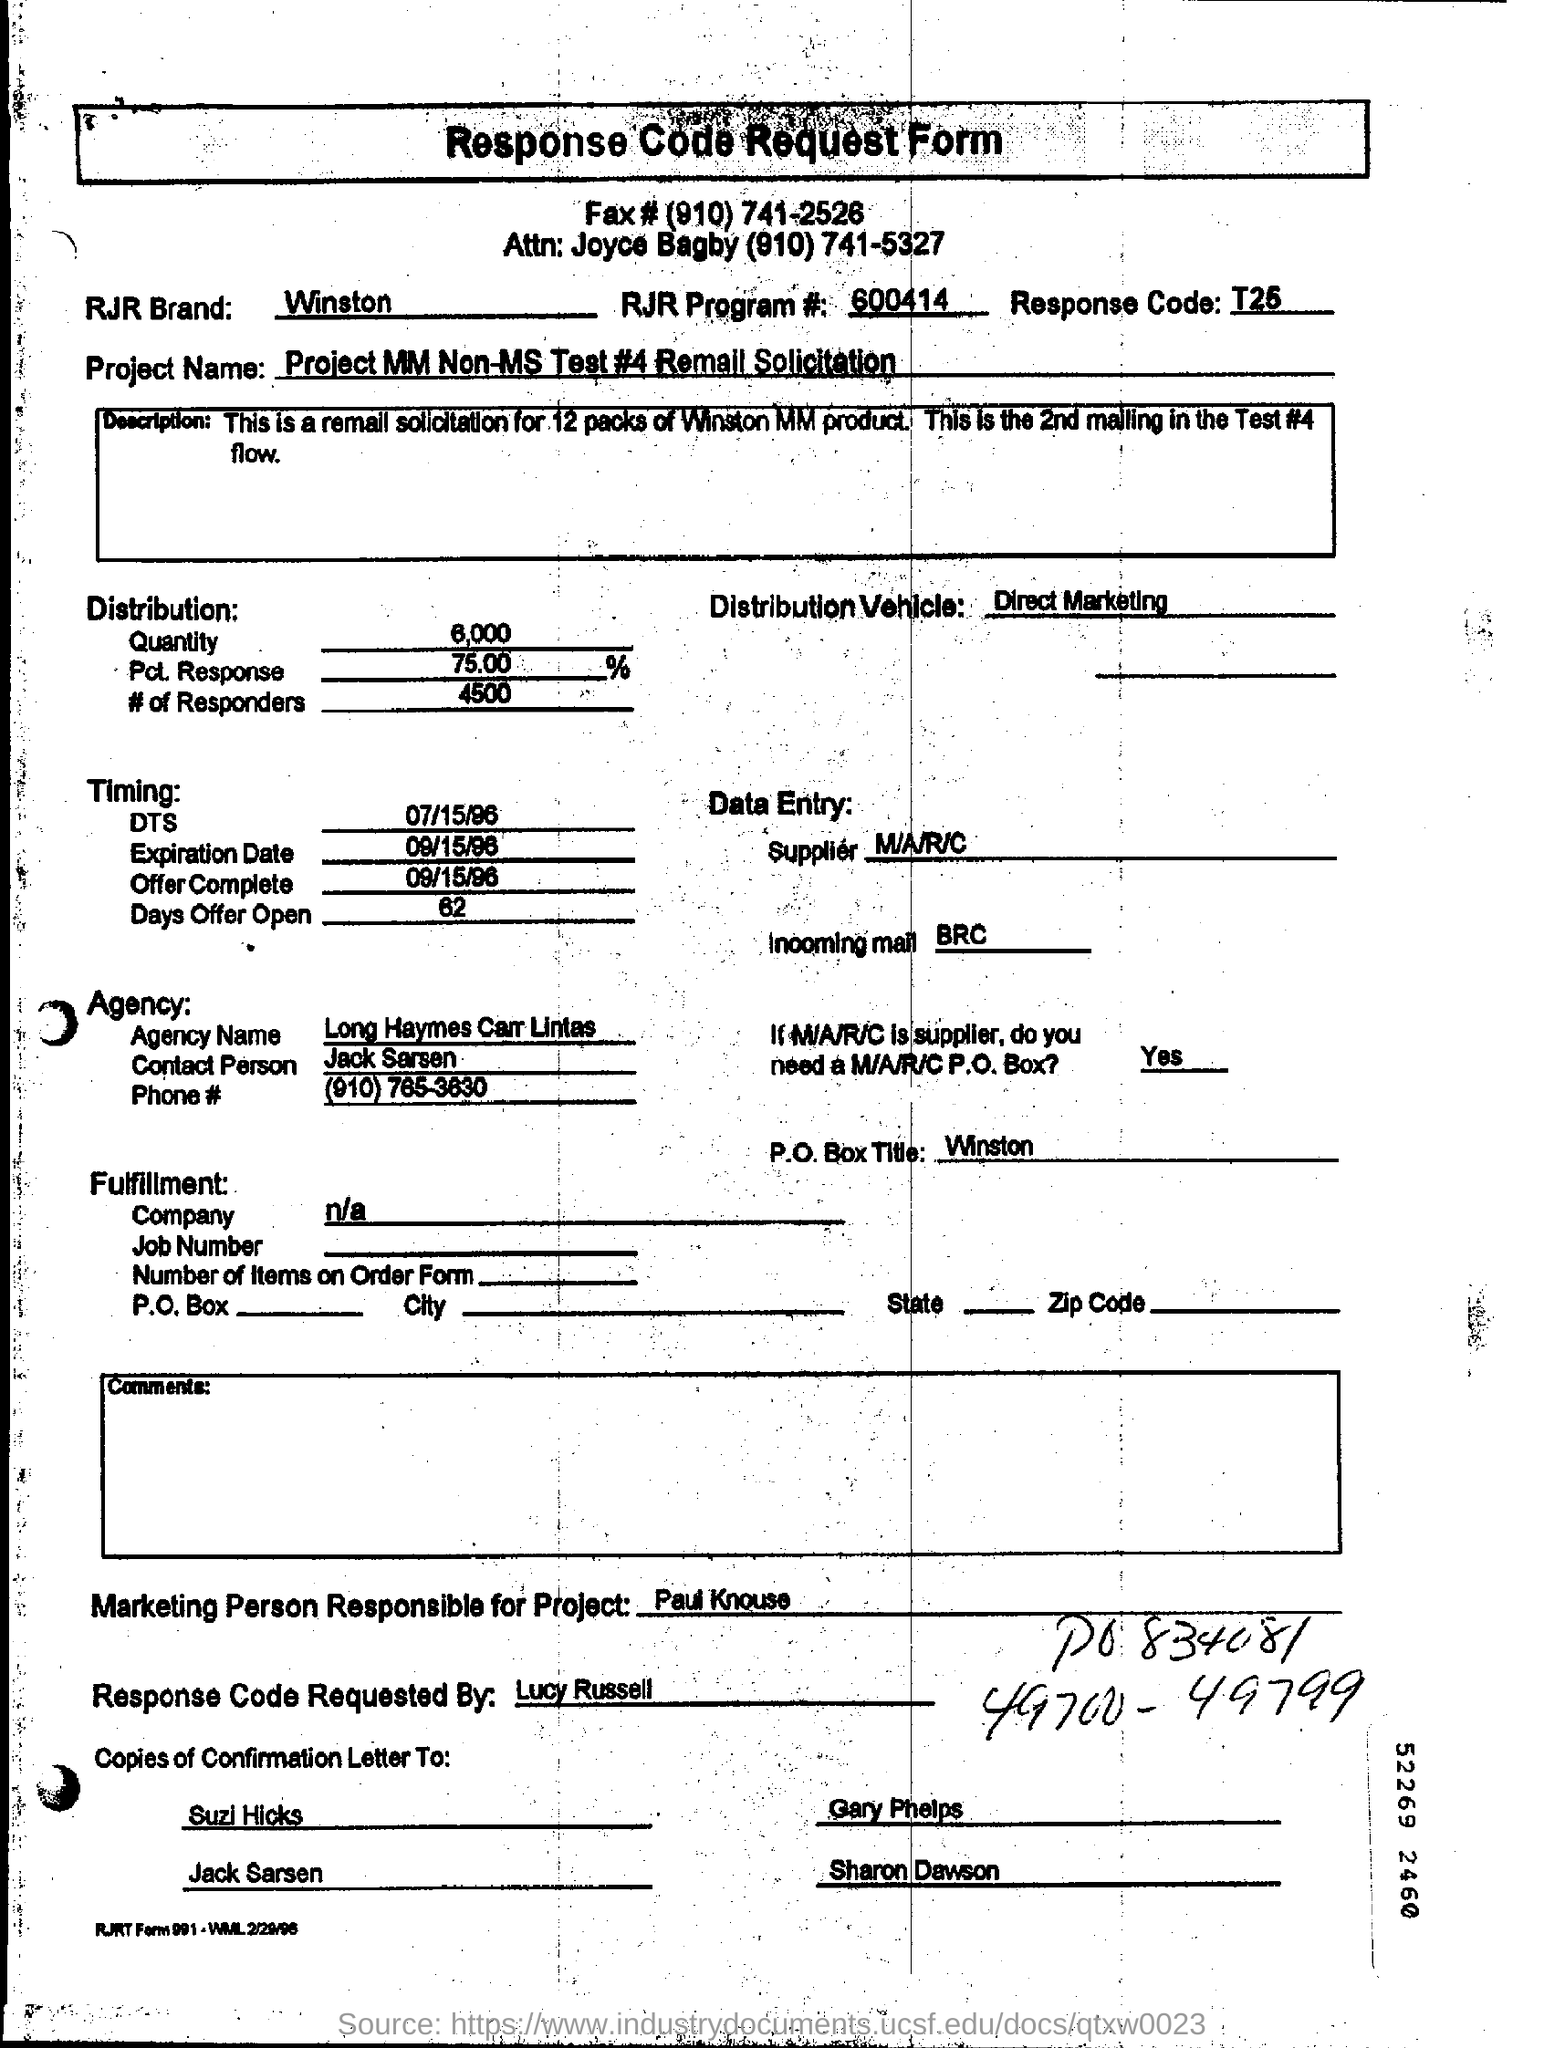What is the RJR Program# mentioned in the form?
Your answer should be very brief. 600414. 